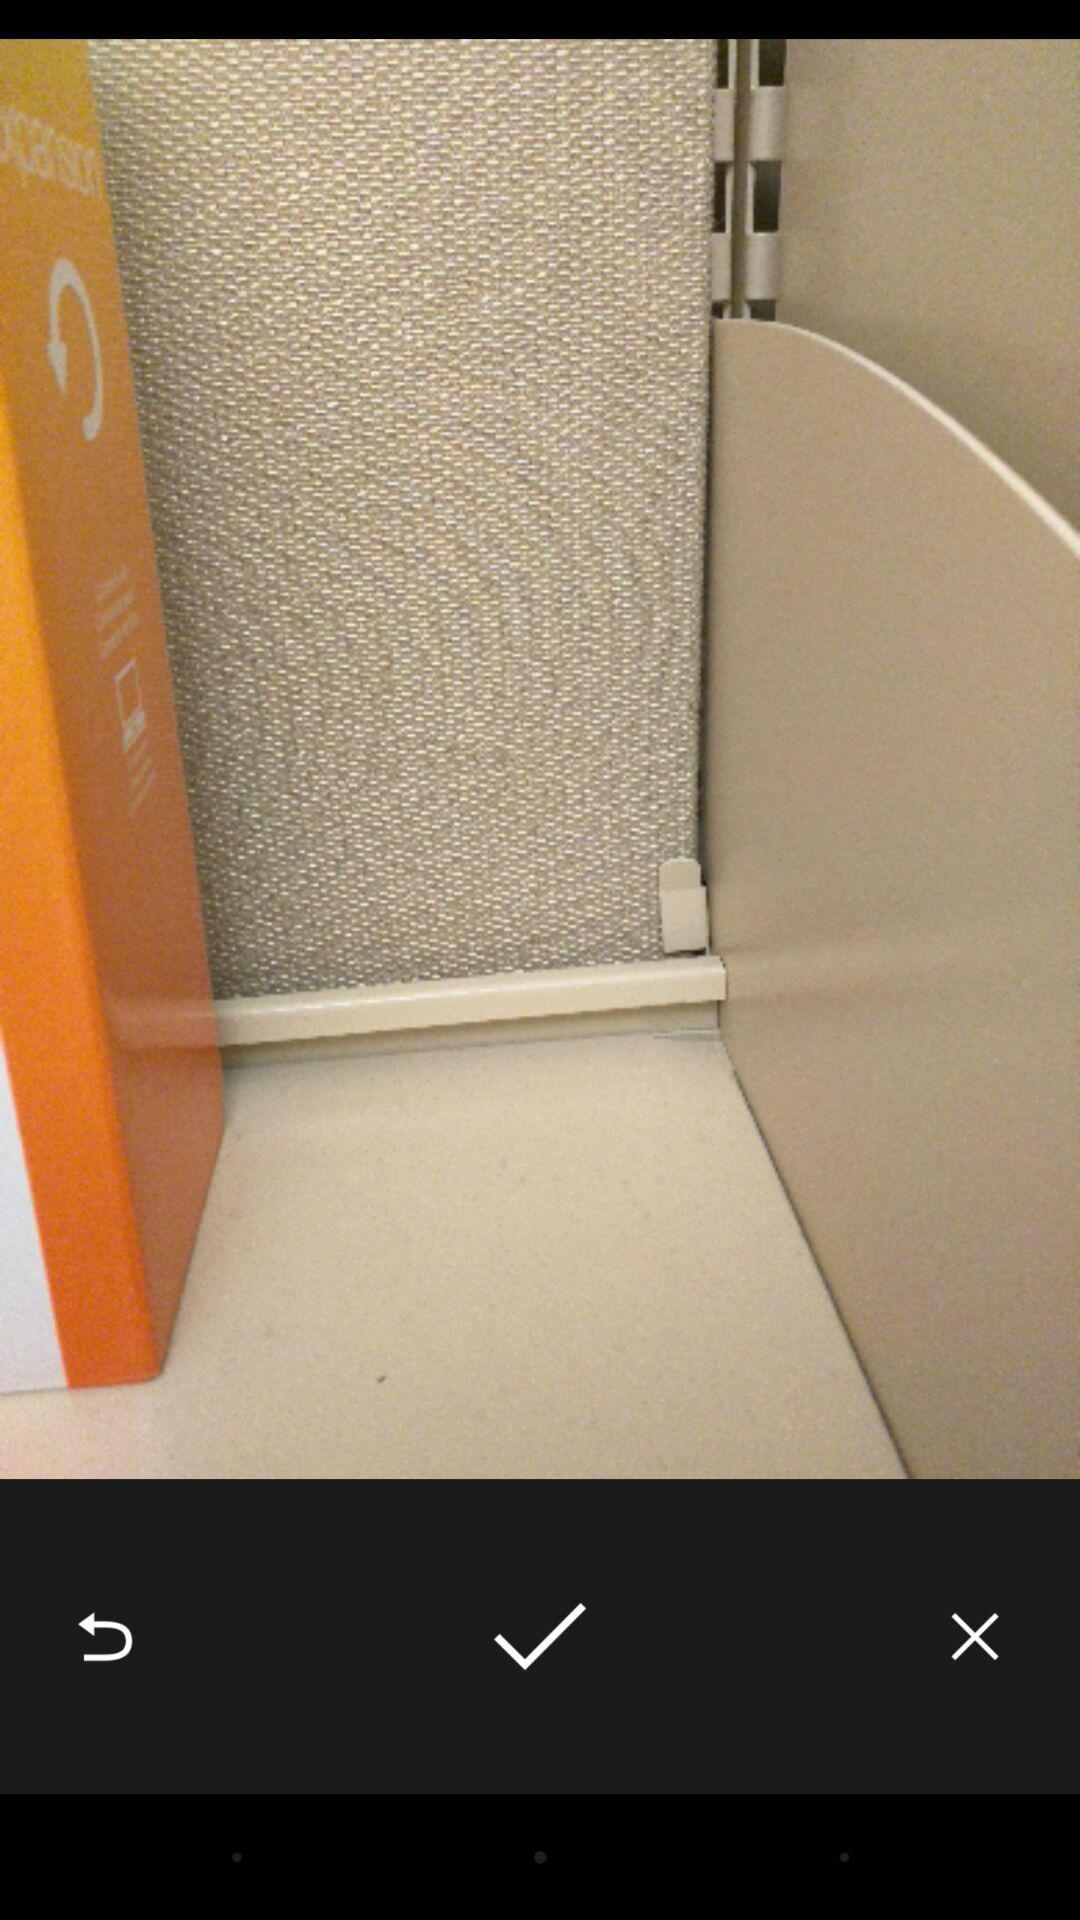What can you discern from this picture? Page showing a picture with a tick below the picture. 